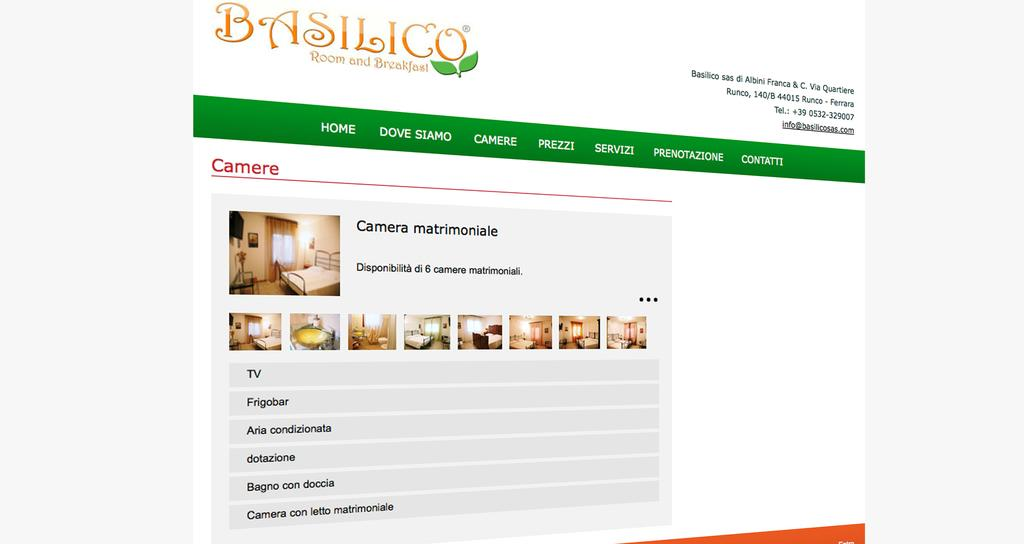What is the main subject of the image? The main subject of the image is a webpage. What can be found on the webpage? There is text on the webpage. How much salt is sprinkled on the hat in the image? There is no hat or salt present in the image; it features a webpage with text. 